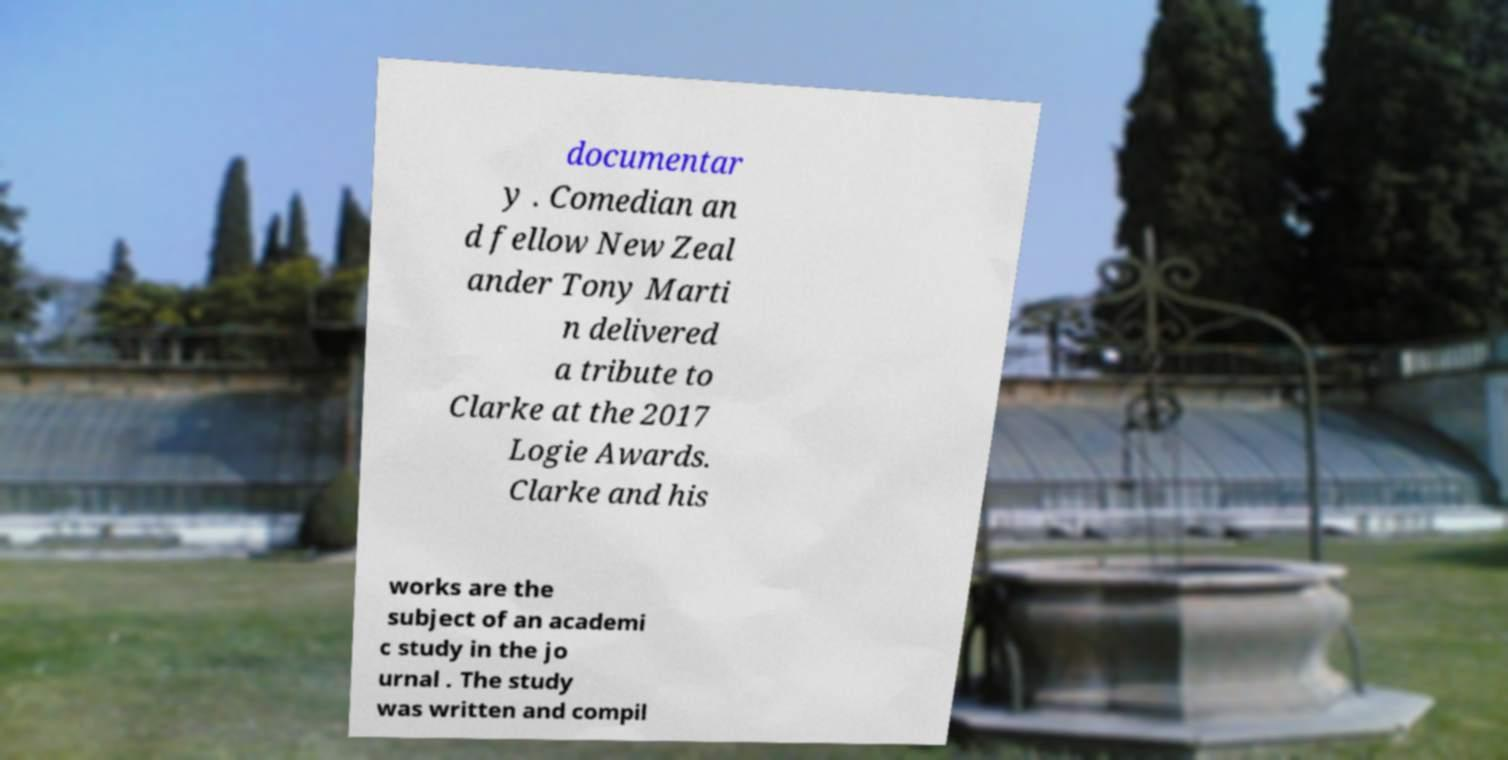Can you read and provide the text displayed in the image?This photo seems to have some interesting text. Can you extract and type it out for me? documentar y . Comedian an d fellow New Zeal ander Tony Marti n delivered a tribute to Clarke at the 2017 Logie Awards. Clarke and his works are the subject of an academi c study in the jo urnal . The study was written and compil 